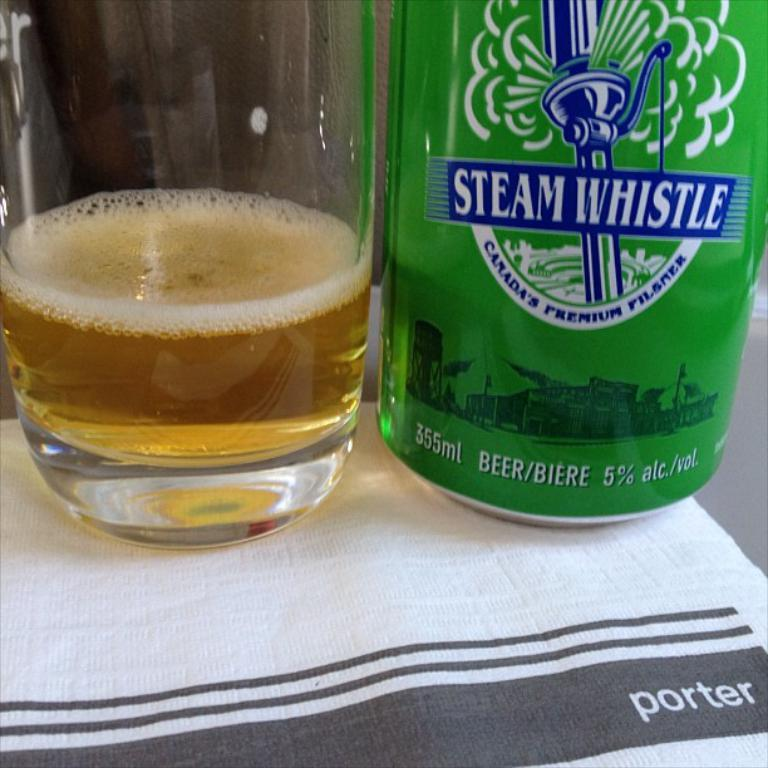<image>
Create a compact narrative representing the image presented. A green can of Steam Whistle pilsner sits by a glass with some golden liquid in it. 